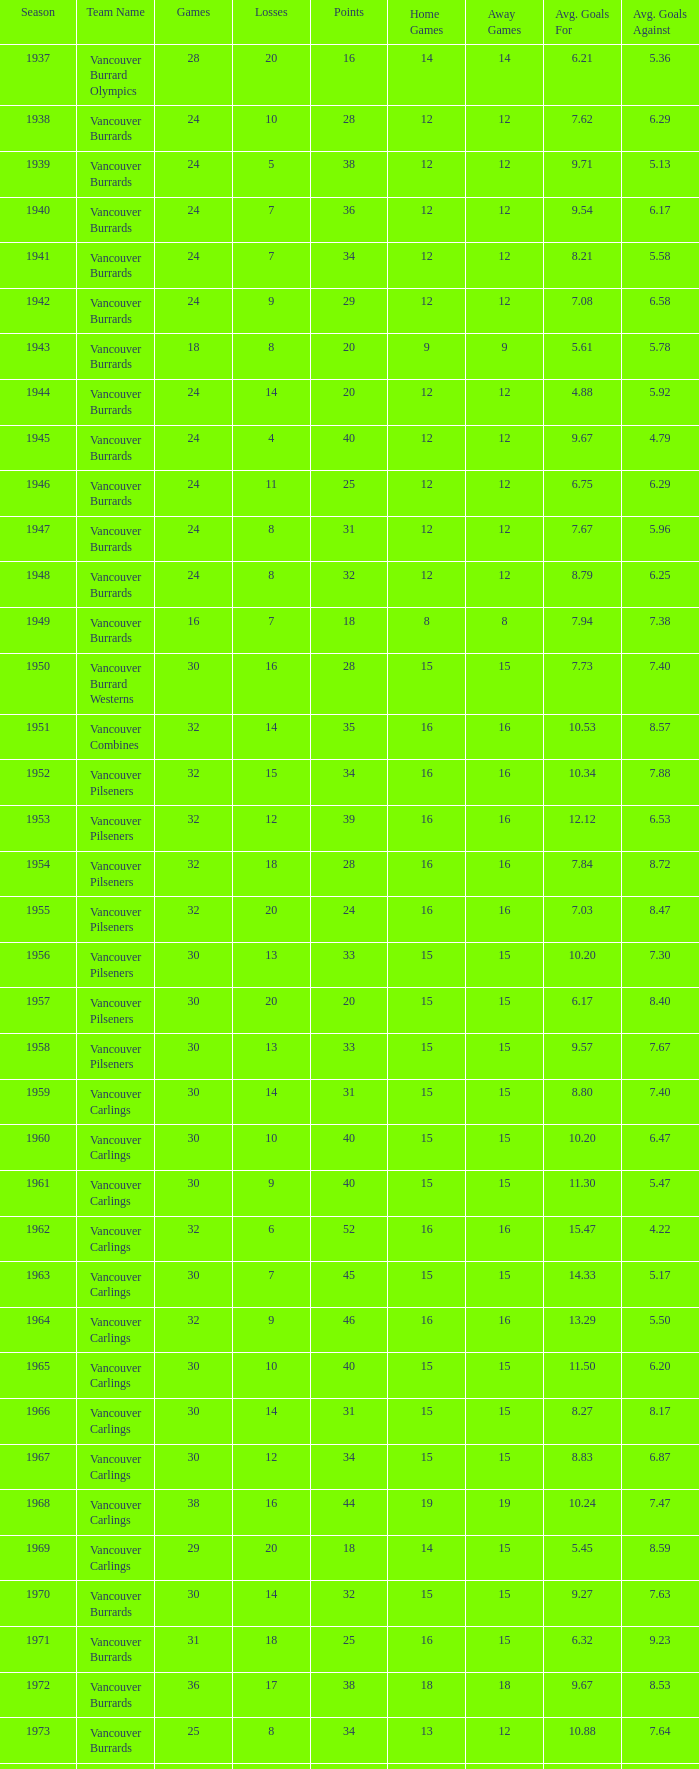What's the total number of points when the vancouver burrards have fewer than 9 losses and more than 24 games? 1.0. 